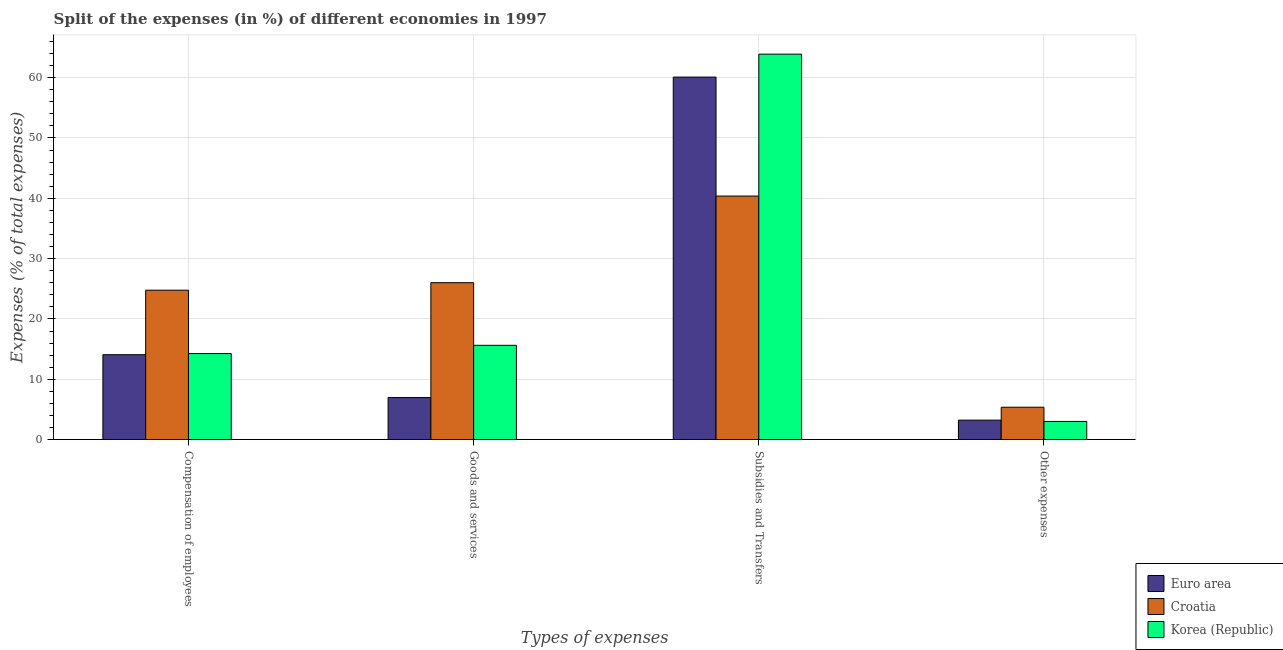How many different coloured bars are there?
Your response must be concise. 3. How many groups of bars are there?
Keep it short and to the point. 4. Are the number of bars per tick equal to the number of legend labels?
Provide a succinct answer. Yes. Are the number of bars on each tick of the X-axis equal?
Offer a terse response. Yes. How many bars are there on the 4th tick from the right?
Offer a terse response. 3. What is the label of the 3rd group of bars from the left?
Provide a short and direct response. Subsidies and Transfers. What is the percentage of amount spent on goods and services in Euro area?
Offer a terse response. 6.97. Across all countries, what is the maximum percentage of amount spent on subsidies?
Your answer should be very brief. 63.9. Across all countries, what is the minimum percentage of amount spent on subsidies?
Your answer should be compact. 40.38. In which country was the percentage of amount spent on compensation of employees maximum?
Your answer should be very brief. Croatia. In which country was the percentage of amount spent on subsidies minimum?
Make the answer very short. Croatia. What is the total percentage of amount spent on goods and services in the graph?
Give a very brief answer. 48.61. What is the difference between the percentage of amount spent on other expenses in Croatia and that in Korea (Republic)?
Make the answer very short. 2.35. What is the difference between the percentage of amount spent on compensation of employees in Korea (Republic) and the percentage of amount spent on other expenses in Euro area?
Make the answer very short. 11.04. What is the average percentage of amount spent on subsidies per country?
Provide a short and direct response. 54.79. What is the difference between the percentage of amount spent on subsidies and percentage of amount spent on goods and services in Croatia?
Your answer should be compact. 14.36. In how many countries, is the percentage of amount spent on subsidies greater than 48 %?
Ensure brevity in your answer.  2. What is the ratio of the percentage of amount spent on goods and services in Korea (Republic) to that in Croatia?
Offer a very short reply. 0.6. Is the difference between the percentage of amount spent on goods and services in Croatia and Euro area greater than the difference between the percentage of amount spent on other expenses in Croatia and Euro area?
Offer a very short reply. Yes. What is the difference between the highest and the second highest percentage of amount spent on other expenses?
Your answer should be compact. 2.14. What is the difference between the highest and the lowest percentage of amount spent on subsidies?
Ensure brevity in your answer.  23.52. In how many countries, is the percentage of amount spent on compensation of employees greater than the average percentage of amount spent on compensation of employees taken over all countries?
Provide a short and direct response. 1. Is it the case that in every country, the sum of the percentage of amount spent on subsidies and percentage of amount spent on compensation of employees is greater than the sum of percentage of amount spent on other expenses and percentage of amount spent on goods and services?
Keep it short and to the point. Yes. What does the 3rd bar from the left in Compensation of employees represents?
Ensure brevity in your answer.  Korea (Republic). What does the 2nd bar from the right in Compensation of employees represents?
Keep it short and to the point. Croatia. How many bars are there?
Provide a short and direct response. 12. Are all the bars in the graph horizontal?
Provide a short and direct response. No. Are the values on the major ticks of Y-axis written in scientific E-notation?
Ensure brevity in your answer.  No. How many legend labels are there?
Ensure brevity in your answer.  3. What is the title of the graph?
Give a very brief answer. Split of the expenses (in %) of different economies in 1997. What is the label or title of the X-axis?
Keep it short and to the point. Types of expenses. What is the label or title of the Y-axis?
Provide a short and direct response. Expenses (% of total expenses). What is the Expenses (% of total expenses) in Euro area in Compensation of employees?
Make the answer very short. 14.08. What is the Expenses (% of total expenses) in Croatia in Compensation of employees?
Your response must be concise. 24.77. What is the Expenses (% of total expenses) in Korea (Republic) in Compensation of employees?
Keep it short and to the point. 14.27. What is the Expenses (% of total expenses) in Euro area in Goods and services?
Ensure brevity in your answer.  6.97. What is the Expenses (% of total expenses) of Croatia in Goods and services?
Provide a succinct answer. 26.01. What is the Expenses (% of total expenses) of Korea (Republic) in Goods and services?
Your answer should be compact. 15.63. What is the Expenses (% of total expenses) in Euro area in Subsidies and Transfers?
Your answer should be very brief. 60.1. What is the Expenses (% of total expenses) of Croatia in Subsidies and Transfers?
Your answer should be very brief. 40.38. What is the Expenses (% of total expenses) in Korea (Republic) in Subsidies and Transfers?
Keep it short and to the point. 63.9. What is the Expenses (% of total expenses) of Euro area in Other expenses?
Your answer should be compact. 3.23. What is the Expenses (% of total expenses) of Croatia in Other expenses?
Give a very brief answer. 5.37. What is the Expenses (% of total expenses) of Korea (Republic) in Other expenses?
Your response must be concise. 3.01. Across all Types of expenses, what is the maximum Expenses (% of total expenses) of Euro area?
Your response must be concise. 60.1. Across all Types of expenses, what is the maximum Expenses (% of total expenses) of Croatia?
Provide a succinct answer. 40.38. Across all Types of expenses, what is the maximum Expenses (% of total expenses) in Korea (Republic)?
Offer a terse response. 63.9. Across all Types of expenses, what is the minimum Expenses (% of total expenses) in Euro area?
Provide a short and direct response. 3.23. Across all Types of expenses, what is the minimum Expenses (% of total expenses) of Croatia?
Keep it short and to the point. 5.37. Across all Types of expenses, what is the minimum Expenses (% of total expenses) in Korea (Republic)?
Your response must be concise. 3.01. What is the total Expenses (% of total expenses) in Euro area in the graph?
Your answer should be compact. 84.37. What is the total Expenses (% of total expenses) in Croatia in the graph?
Ensure brevity in your answer.  96.52. What is the total Expenses (% of total expenses) in Korea (Republic) in the graph?
Provide a short and direct response. 96.81. What is the difference between the Expenses (% of total expenses) of Euro area in Compensation of employees and that in Goods and services?
Ensure brevity in your answer.  7.1. What is the difference between the Expenses (% of total expenses) in Croatia in Compensation of employees and that in Goods and services?
Make the answer very short. -1.24. What is the difference between the Expenses (% of total expenses) in Korea (Republic) in Compensation of employees and that in Goods and services?
Keep it short and to the point. -1.36. What is the difference between the Expenses (% of total expenses) in Euro area in Compensation of employees and that in Subsidies and Transfers?
Your answer should be very brief. -46.02. What is the difference between the Expenses (% of total expenses) of Croatia in Compensation of employees and that in Subsidies and Transfers?
Provide a succinct answer. -15.61. What is the difference between the Expenses (% of total expenses) in Korea (Republic) in Compensation of employees and that in Subsidies and Transfers?
Ensure brevity in your answer.  -49.63. What is the difference between the Expenses (% of total expenses) in Euro area in Compensation of employees and that in Other expenses?
Keep it short and to the point. 10.85. What is the difference between the Expenses (% of total expenses) of Croatia in Compensation of employees and that in Other expenses?
Keep it short and to the point. 19.4. What is the difference between the Expenses (% of total expenses) of Korea (Republic) in Compensation of employees and that in Other expenses?
Ensure brevity in your answer.  11.25. What is the difference between the Expenses (% of total expenses) in Euro area in Goods and services and that in Subsidies and Transfers?
Provide a short and direct response. -53.12. What is the difference between the Expenses (% of total expenses) of Croatia in Goods and services and that in Subsidies and Transfers?
Provide a succinct answer. -14.36. What is the difference between the Expenses (% of total expenses) of Korea (Republic) in Goods and services and that in Subsidies and Transfers?
Keep it short and to the point. -48.27. What is the difference between the Expenses (% of total expenses) in Euro area in Goods and services and that in Other expenses?
Your answer should be compact. 3.75. What is the difference between the Expenses (% of total expenses) in Croatia in Goods and services and that in Other expenses?
Make the answer very short. 20.64. What is the difference between the Expenses (% of total expenses) of Korea (Republic) in Goods and services and that in Other expenses?
Keep it short and to the point. 12.62. What is the difference between the Expenses (% of total expenses) in Euro area in Subsidies and Transfers and that in Other expenses?
Your answer should be very brief. 56.87. What is the difference between the Expenses (% of total expenses) in Croatia in Subsidies and Transfers and that in Other expenses?
Provide a succinct answer. 35.01. What is the difference between the Expenses (% of total expenses) in Korea (Republic) in Subsidies and Transfers and that in Other expenses?
Provide a succinct answer. 60.88. What is the difference between the Expenses (% of total expenses) in Euro area in Compensation of employees and the Expenses (% of total expenses) in Croatia in Goods and services?
Provide a succinct answer. -11.94. What is the difference between the Expenses (% of total expenses) of Euro area in Compensation of employees and the Expenses (% of total expenses) of Korea (Republic) in Goods and services?
Your answer should be very brief. -1.55. What is the difference between the Expenses (% of total expenses) in Croatia in Compensation of employees and the Expenses (% of total expenses) in Korea (Republic) in Goods and services?
Provide a succinct answer. 9.14. What is the difference between the Expenses (% of total expenses) in Euro area in Compensation of employees and the Expenses (% of total expenses) in Croatia in Subsidies and Transfers?
Your answer should be very brief. -26.3. What is the difference between the Expenses (% of total expenses) of Euro area in Compensation of employees and the Expenses (% of total expenses) of Korea (Republic) in Subsidies and Transfers?
Offer a terse response. -49.82. What is the difference between the Expenses (% of total expenses) in Croatia in Compensation of employees and the Expenses (% of total expenses) in Korea (Republic) in Subsidies and Transfers?
Make the answer very short. -39.13. What is the difference between the Expenses (% of total expenses) of Euro area in Compensation of employees and the Expenses (% of total expenses) of Croatia in Other expenses?
Provide a short and direct response. 8.71. What is the difference between the Expenses (% of total expenses) of Euro area in Compensation of employees and the Expenses (% of total expenses) of Korea (Republic) in Other expenses?
Your answer should be very brief. 11.06. What is the difference between the Expenses (% of total expenses) in Croatia in Compensation of employees and the Expenses (% of total expenses) in Korea (Republic) in Other expenses?
Your answer should be very brief. 21.75. What is the difference between the Expenses (% of total expenses) in Euro area in Goods and services and the Expenses (% of total expenses) in Croatia in Subsidies and Transfers?
Offer a terse response. -33.4. What is the difference between the Expenses (% of total expenses) in Euro area in Goods and services and the Expenses (% of total expenses) in Korea (Republic) in Subsidies and Transfers?
Your answer should be compact. -56.92. What is the difference between the Expenses (% of total expenses) in Croatia in Goods and services and the Expenses (% of total expenses) in Korea (Republic) in Subsidies and Transfers?
Your answer should be compact. -37.89. What is the difference between the Expenses (% of total expenses) of Euro area in Goods and services and the Expenses (% of total expenses) of Croatia in Other expenses?
Your answer should be compact. 1.61. What is the difference between the Expenses (% of total expenses) in Euro area in Goods and services and the Expenses (% of total expenses) in Korea (Republic) in Other expenses?
Make the answer very short. 3.96. What is the difference between the Expenses (% of total expenses) of Croatia in Goods and services and the Expenses (% of total expenses) of Korea (Republic) in Other expenses?
Your answer should be very brief. 23. What is the difference between the Expenses (% of total expenses) in Euro area in Subsidies and Transfers and the Expenses (% of total expenses) in Croatia in Other expenses?
Your answer should be very brief. 54.73. What is the difference between the Expenses (% of total expenses) of Euro area in Subsidies and Transfers and the Expenses (% of total expenses) of Korea (Republic) in Other expenses?
Ensure brevity in your answer.  57.08. What is the difference between the Expenses (% of total expenses) in Croatia in Subsidies and Transfers and the Expenses (% of total expenses) in Korea (Republic) in Other expenses?
Offer a very short reply. 37.36. What is the average Expenses (% of total expenses) in Euro area per Types of expenses?
Provide a succinct answer. 21.09. What is the average Expenses (% of total expenses) of Croatia per Types of expenses?
Make the answer very short. 24.13. What is the average Expenses (% of total expenses) in Korea (Republic) per Types of expenses?
Give a very brief answer. 24.2. What is the difference between the Expenses (% of total expenses) of Euro area and Expenses (% of total expenses) of Croatia in Compensation of employees?
Your answer should be compact. -10.69. What is the difference between the Expenses (% of total expenses) of Euro area and Expenses (% of total expenses) of Korea (Republic) in Compensation of employees?
Give a very brief answer. -0.19. What is the difference between the Expenses (% of total expenses) of Croatia and Expenses (% of total expenses) of Korea (Republic) in Compensation of employees?
Provide a succinct answer. 10.5. What is the difference between the Expenses (% of total expenses) in Euro area and Expenses (% of total expenses) in Croatia in Goods and services?
Give a very brief answer. -19.04. What is the difference between the Expenses (% of total expenses) of Euro area and Expenses (% of total expenses) of Korea (Republic) in Goods and services?
Your answer should be very brief. -8.65. What is the difference between the Expenses (% of total expenses) of Croatia and Expenses (% of total expenses) of Korea (Republic) in Goods and services?
Offer a very short reply. 10.38. What is the difference between the Expenses (% of total expenses) of Euro area and Expenses (% of total expenses) of Croatia in Subsidies and Transfers?
Your answer should be compact. 19.72. What is the difference between the Expenses (% of total expenses) in Euro area and Expenses (% of total expenses) in Korea (Republic) in Subsidies and Transfers?
Offer a very short reply. -3.8. What is the difference between the Expenses (% of total expenses) of Croatia and Expenses (% of total expenses) of Korea (Republic) in Subsidies and Transfers?
Ensure brevity in your answer.  -23.52. What is the difference between the Expenses (% of total expenses) of Euro area and Expenses (% of total expenses) of Croatia in Other expenses?
Ensure brevity in your answer.  -2.14. What is the difference between the Expenses (% of total expenses) of Euro area and Expenses (% of total expenses) of Korea (Republic) in Other expenses?
Your answer should be very brief. 0.21. What is the difference between the Expenses (% of total expenses) in Croatia and Expenses (% of total expenses) in Korea (Republic) in Other expenses?
Offer a very short reply. 2.35. What is the ratio of the Expenses (% of total expenses) of Euro area in Compensation of employees to that in Goods and services?
Provide a succinct answer. 2.02. What is the ratio of the Expenses (% of total expenses) in Croatia in Compensation of employees to that in Goods and services?
Keep it short and to the point. 0.95. What is the ratio of the Expenses (% of total expenses) of Korea (Republic) in Compensation of employees to that in Goods and services?
Your answer should be very brief. 0.91. What is the ratio of the Expenses (% of total expenses) of Euro area in Compensation of employees to that in Subsidies and Transfers?
Keep it short and to the point. 0.23. What is the ratio of the Expenses (% of total expenses) of Croatia in Compensation of employees to that in Subsidies and Transfers?
Provide a short and direct response. 0.61. What is the ratio of the Expenses (% of total expenses) in Korea (Republic) in Compensation of employees to that in Subsidies and Transfers?
Offer a very short reply. 0.22. What is the ratio of the Expenses (% of total expenses) in Euro area in Compensation of employees to that in Other expenses?
Give a very brief answer. 4.36. What is the ratio of the Expenses (% of total expenses) in Croatia in Compensation of employees to that in Other expenses?
Offer a very short reply. 4.62. What is the ratio of the Expenses (% of total expenses) in Korea (Republic) in Compensation of employees to that in Other expenses?
Your response must be concise. 4.73. What is the ratio of the Expenses (% of total expenses) in Euro area in Goods and services to that in Subsidies and Transfers?
Your answer should be compact. 0.12. What is the ratio of the Expenses (% of total expenses) of Croatia in Goods and services to that in Subsidies and Transfers?
Your response must be concise. 0.64. What is the ratio of the Expenses (% of total expenses) of Korea (Republic) in Goods and services to that in Subsidies and Transfers?
Your answer should be very brief. 0.24. What is the ratio of the Expenses (% of total expenses) of Euro area in Goods and services to that in Other expenses?
Ensure brevity in your answer.  2.16. What is the ratio of the Expenses (% of total expenses) of Croatia in Goods and services to that in Other expenses?
Give a very brief answer. 4.85. What is the ratio of the Expenses (% of total expenses) in Korea (Republic) in Goods and services to that in Other expenses?
Offer a terse response. 5.19. What is the ratio of the Expenses (% of total expenses) of Euro area in Subsidies and Transfers to that in Other expenses?
Offer a terse response. 18.63. What is the ratio of the Expenses (% of total expenses) of Croatia in Subsidies and Transfers to that in Other expenses?
Your answer should be compact. 7.52. What is the ratio of the Expenses (% of total expenses) of Korea (Republic) in Subsidies and Transfers to that in Other expenses?
Offer a terse response. 21.2. What is the difference between the highest and the second highest Expenses (% of total expenses) in Euro area?
Your response must be concise. 46.02. What is the difference between the highest and the second highest Expenses (% of total expenses) in Croatia?
Provide a succinct answer. 14.36. What is the difference between the highest and the second highest Expenses (% of total expenses) of Korea (Republic)?
Ensure brevity in your answer.  48.27. What is the difference between the highest and the lowest Expenses (% of total expenses) in Euro area?
Give a very brief answer. 56.87. What is the difference between the highest and the lowest Expenses (% of total expenses) in Croatia?
Your answer should be very brief. 35.01. What is the difference between the highest and the lowest Expenses (% of total expenses) in Korea (Republic)?
Offer a very short reply. 60.88. 